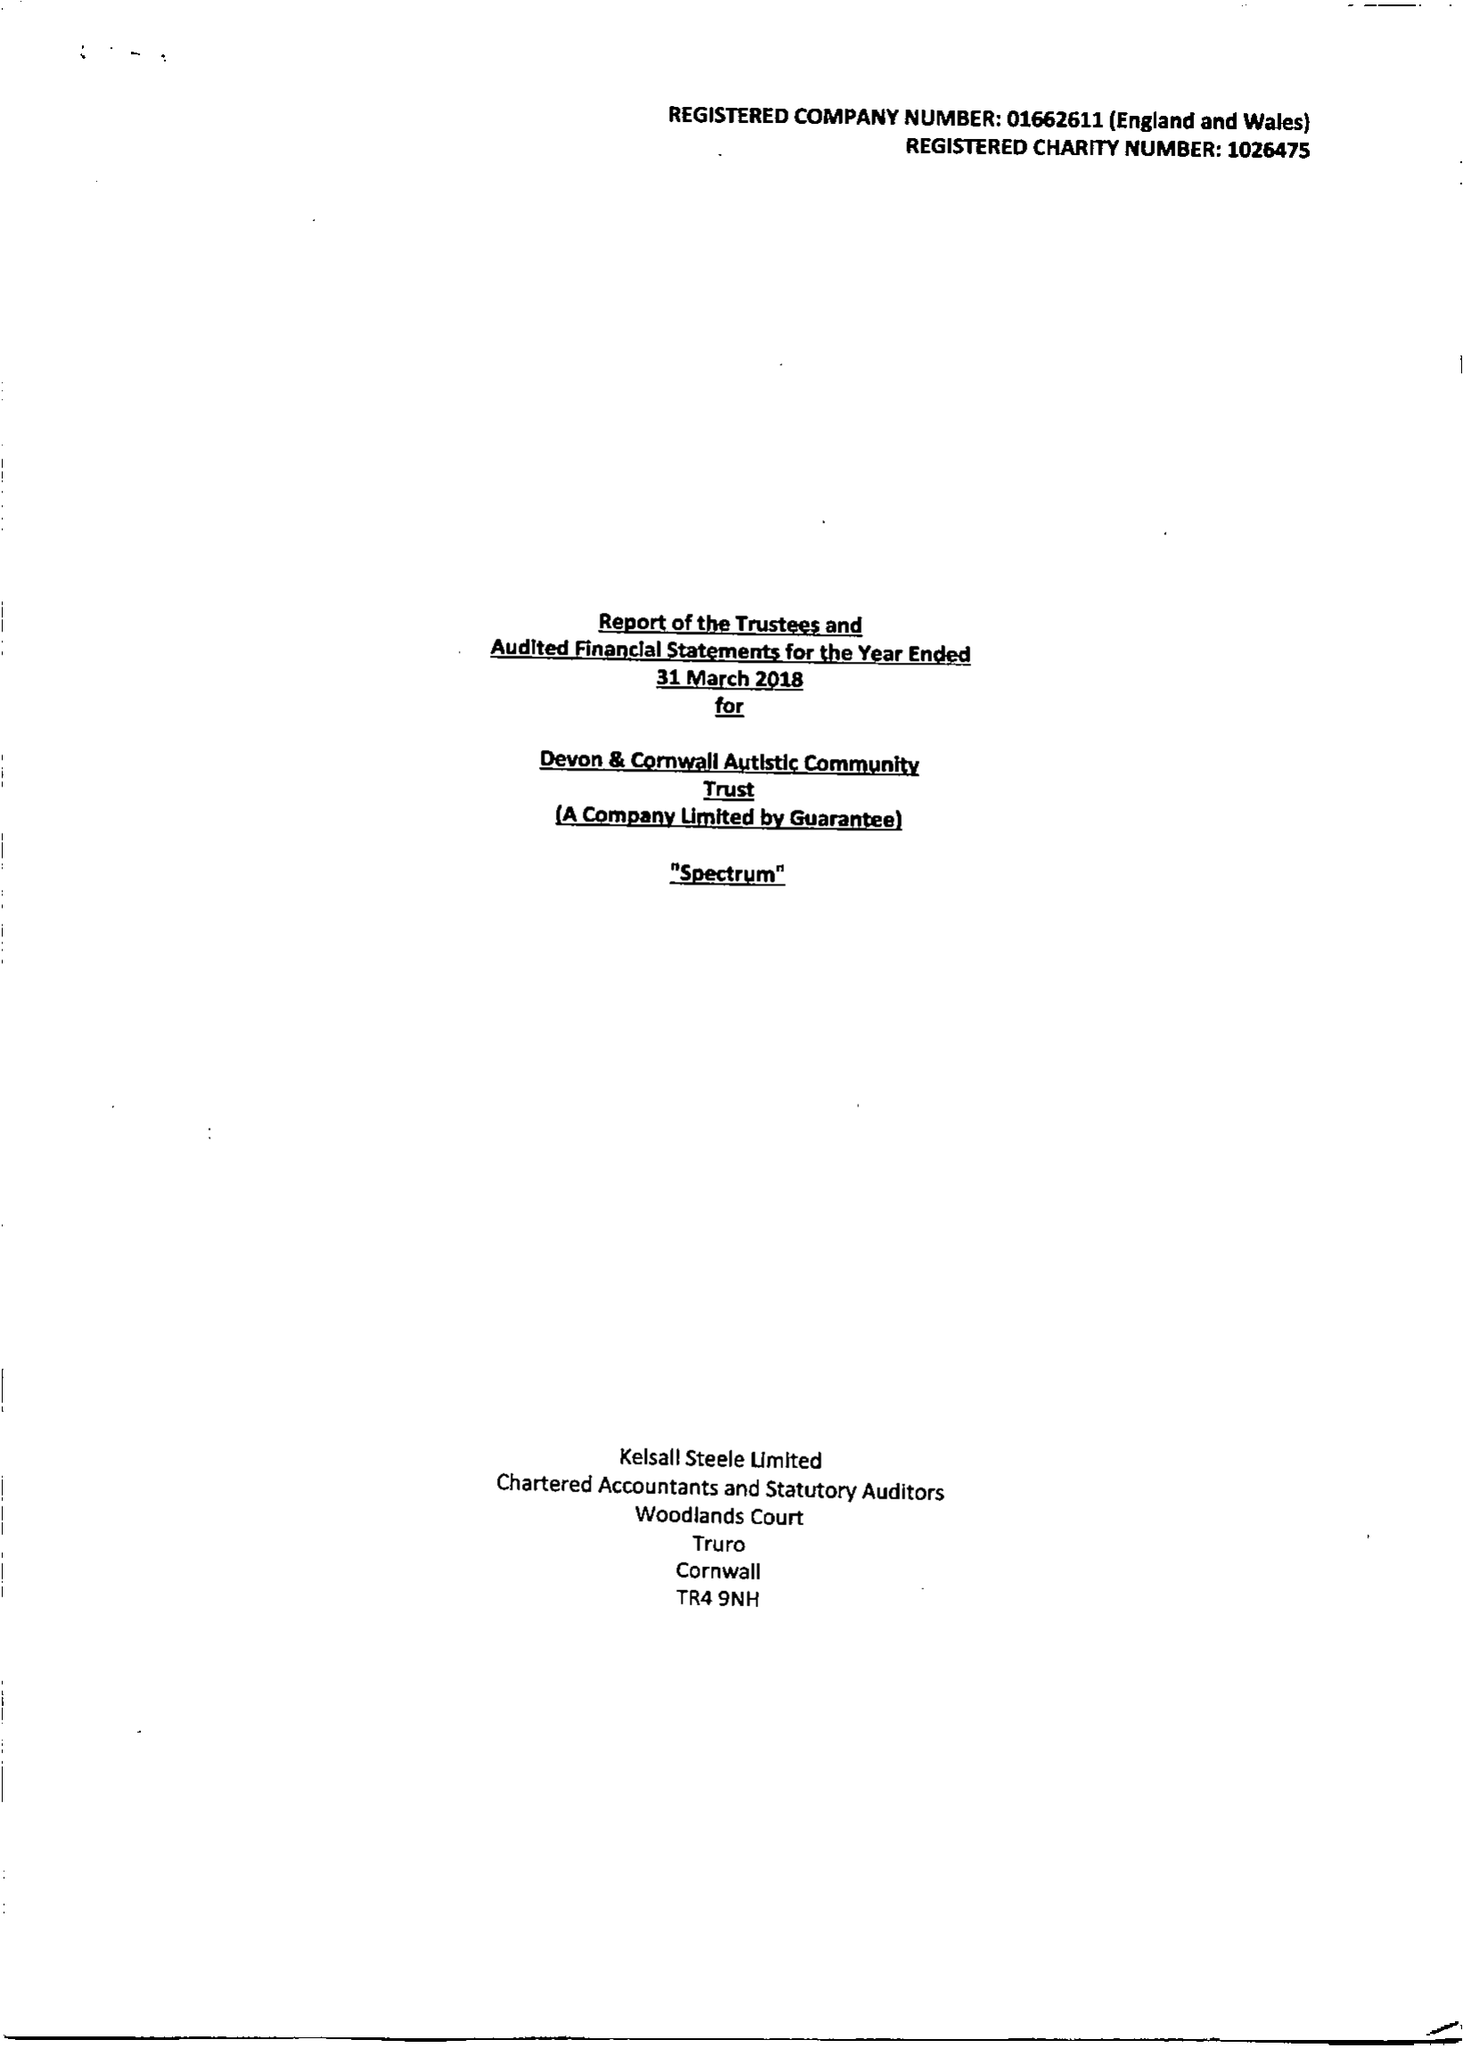What is the value for the income_annually_in_british_pounds?
Answer the question using a single word or phrase. 11263999.00 